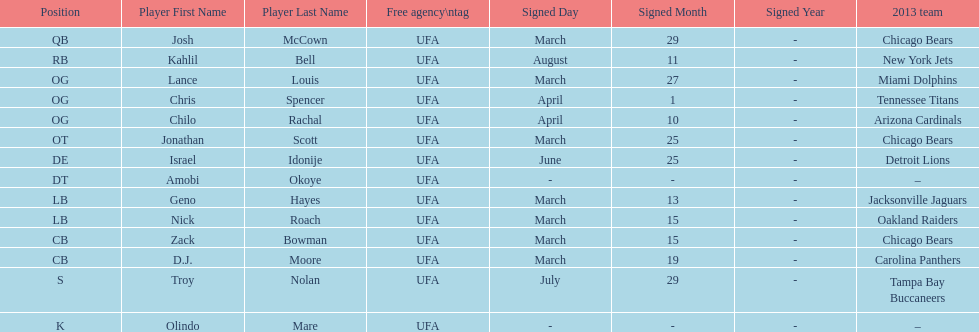The top played position according to this chart. OG. 